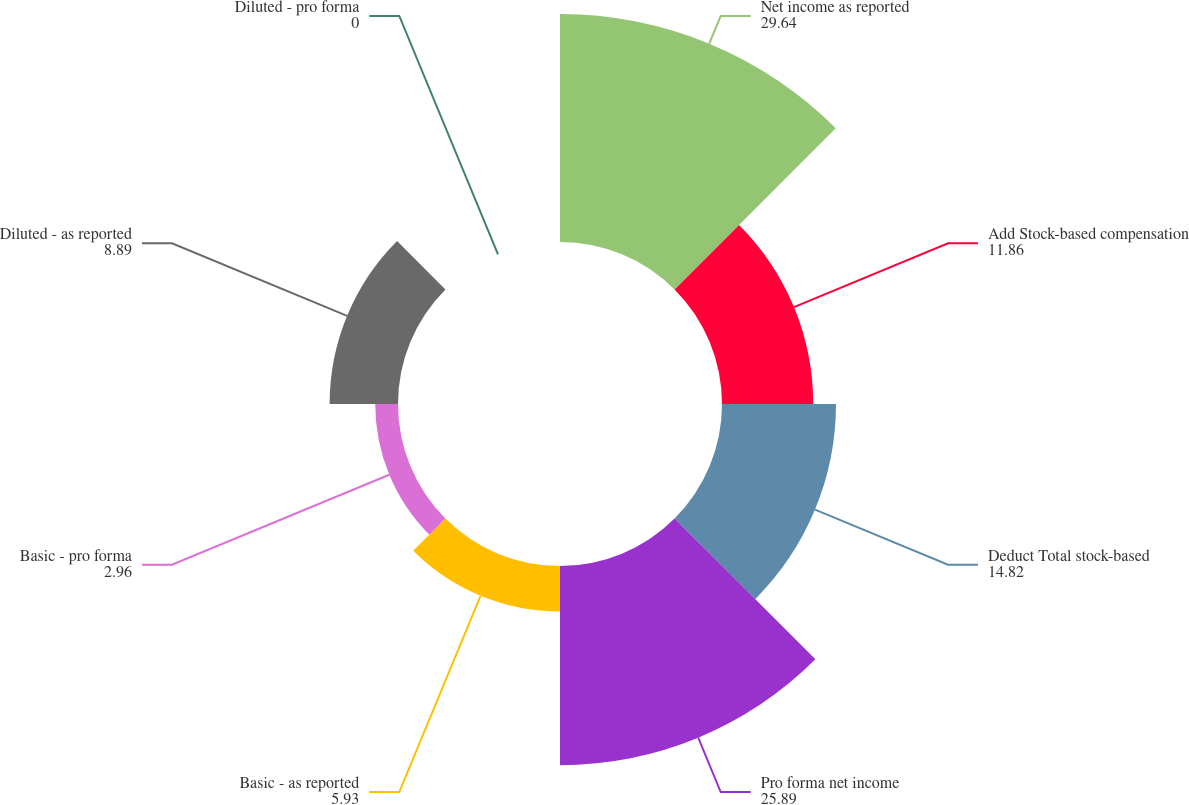<chart> <loc_0><loc_0><loc_500><loc_500><pie_chart><fcel>Net income as reported<fcel>Add Stock-based compensation<fcel>Deduct Total stock-based<fcel>Pro forma net income<fcel>Basic - as reported<fcel>Basic - pro forma<fcel>Diluted - as reported<fcel>Diluted - pro forma<nl><fcel>29.64%<fcel>11.86%<fcel>14.82%<fcel>25.89%<fcel>5.93%<fcel>2.96%<fcel>8.89%<fcel>0.0%<nl></chart> 